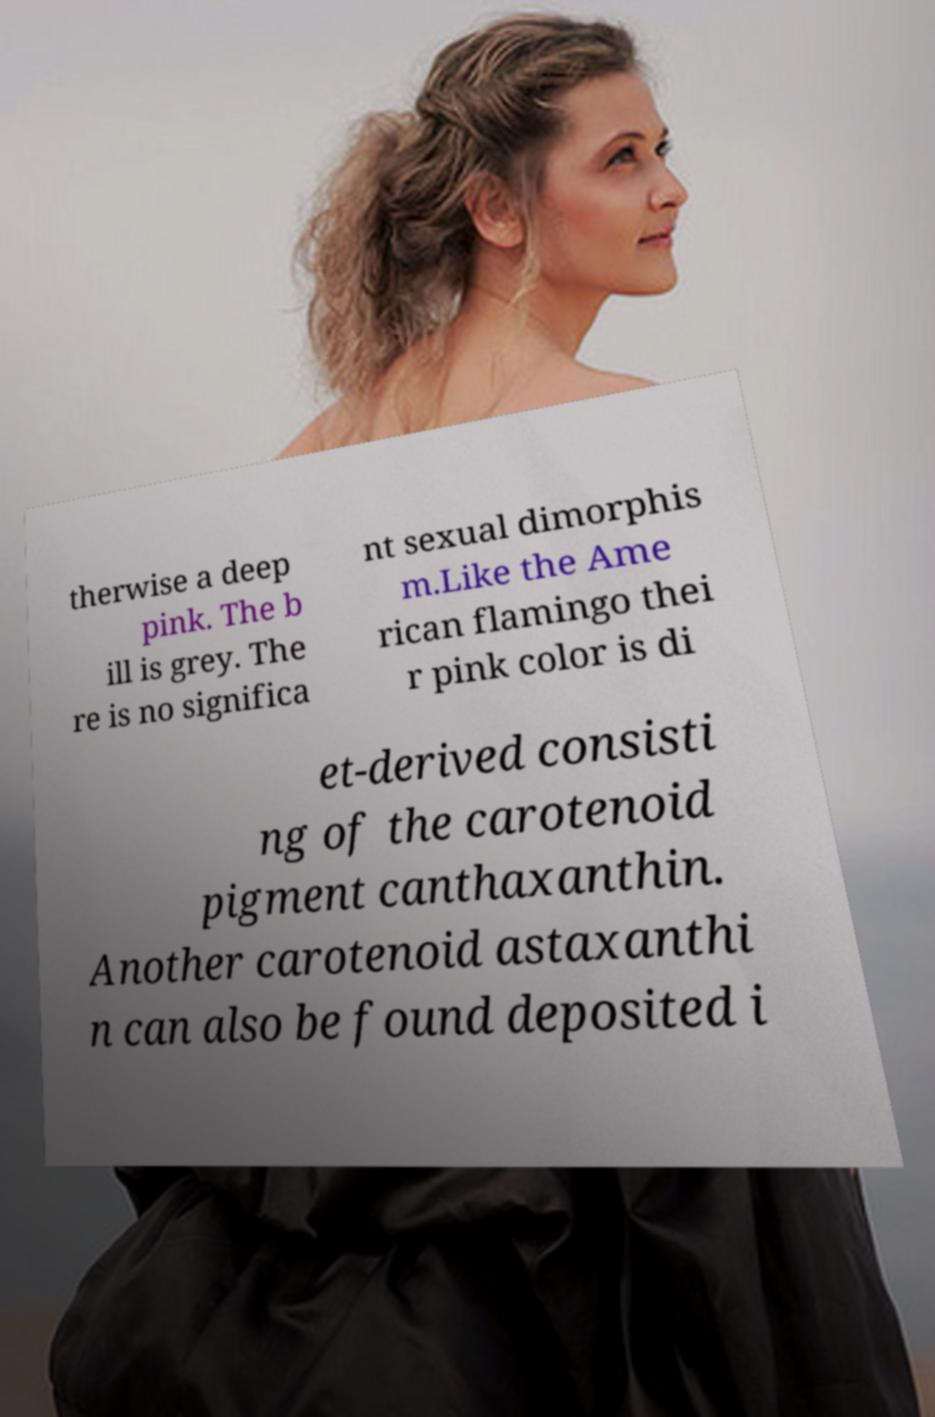There's text embedded in this image that I need extracted. Can you transcribe it verbatim? therwise a deep pink. The b ill is grey. The re is no significa nt sexual dimorphis m.Like the Ame rican flamingo thei r pink color is di et-derived consisti ng of the carotenoid pigment canthaxanthin. Another carotenoid astaxanthi n can also be found deposited i 